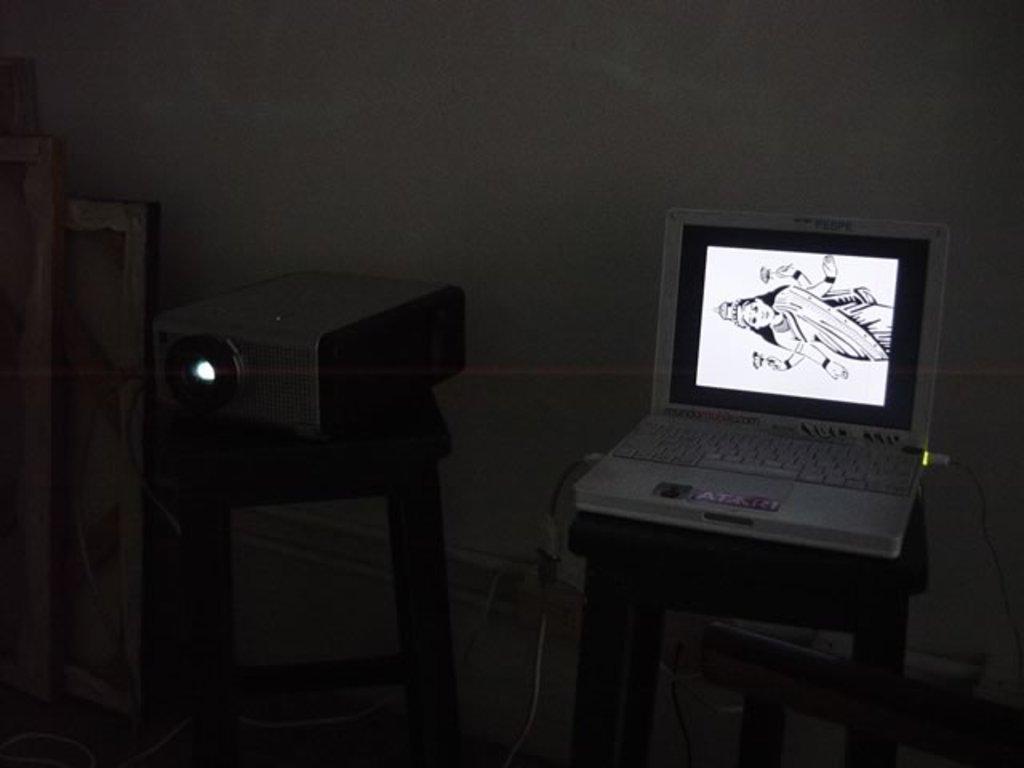How would you summarize this image in a sentence or two? This image is taken indoors. In the background there is a wall. At the bottom of the image there is a floor. On the right side of the image there is a laptop on the stool. There is an image of a goddess on the screen of a laptop. In the middle of the image there is an electronic device on the stool. On the left side of the image there are a few objects. 